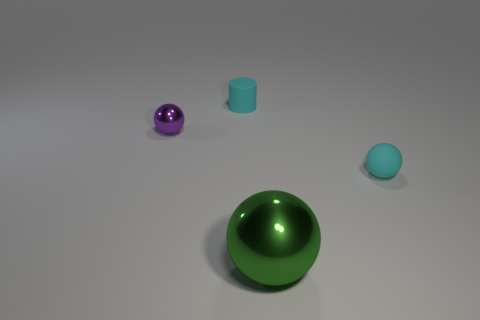Subtract all red spheres. Subtract all blue cylinders. How many spheres are left? 3 Add 1 purple metallic objects. How many objects exist? 5 Subtract all cylinders. How many objects are left? 3 Add 4 small spheres. How many small spheres exist? 6 Subtract 0 purple cylinders. How many objects are left? 4 Subtract all tiny purple shiny balls. Subtract all matte cylinders. How many objects are left? 2 Add 1 green metallic balls. How many green metallic balls are left? 2 